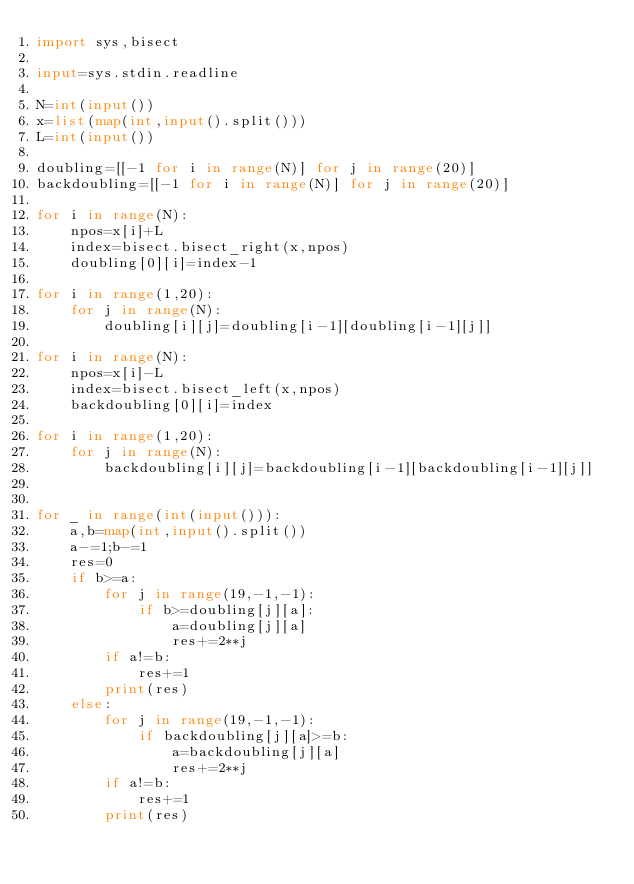<code> <loc_0><loc_0><loc_500><loc_500><_Python_>import sys,bisect

input=sys.stdin.readline

N=int(input())
x=list(map(int,input().split()))
L=int(input())

doubling=[[-1 for i in range(N)] for j in range(20)]
backdoubling=[[-1 for i in range(N)] for j in range(20)]

for i in range(N):
    npos=x[i]+L
    index=bisect.bisect_right(x,npos)
    doubling[0][i]=index-1

for i in range(1,20):
    for j in range(N):
        doubling[i][j]=doubling[i-1][doubling[i-1][j]]

for i in range(N):
    npos=x[i]-L
    index=bisect.bisect_left(x,npos)
    backdoubling[0][i]=index

for i in range(1,20):
    for j in range(N):
        backdoubling[i][j]=backdoubling[i-1][backdoubling[i-1][j]]


for _ in range(int(input())):
    a,b=map(int,input().split())
    a-=1;b-=1
    res=0
    if b>=a:
        for j in range(19,-1,-1):
            if b>=doubling[j][a]:
                a=doubling[j][a]
                res+=2**j
        if a!=b:
            res+=1
        print(res)
    else:
        for j in range(19,-1,-1):
            if backdoubling[j][a]>=b:
                a=backdoubling[j][a]
                res+=2**j
        if a!=b:
            res+=1
        print(res)
</code> 